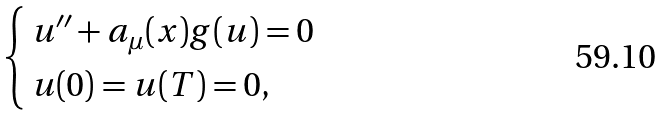<formula> <loc_0><loc_0><loc_500><loc_500>\begin{cases} \, u ^ { \prime \prime } + a _ { \mu } ( x ) g ( u ) = 0 \\ \, u ( 0 ) = u ( T ) = 0 , \end{cases}</formula> 